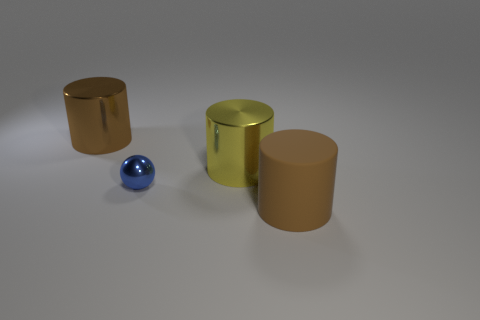What number of other things are there of the same size as the shiny sphere? In the image, there are no other objects that match the exact size of the shiny sphere. The closest in shape are the cylindrical objects, but they are larger than the sphere. 